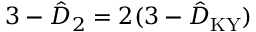<formula> <loc_0><loc_0><loc_500><loc_500>3 - \hat { D } _ { 2 } = 2 ( 3 - \hat { D } _ { K Y } )</formula> 